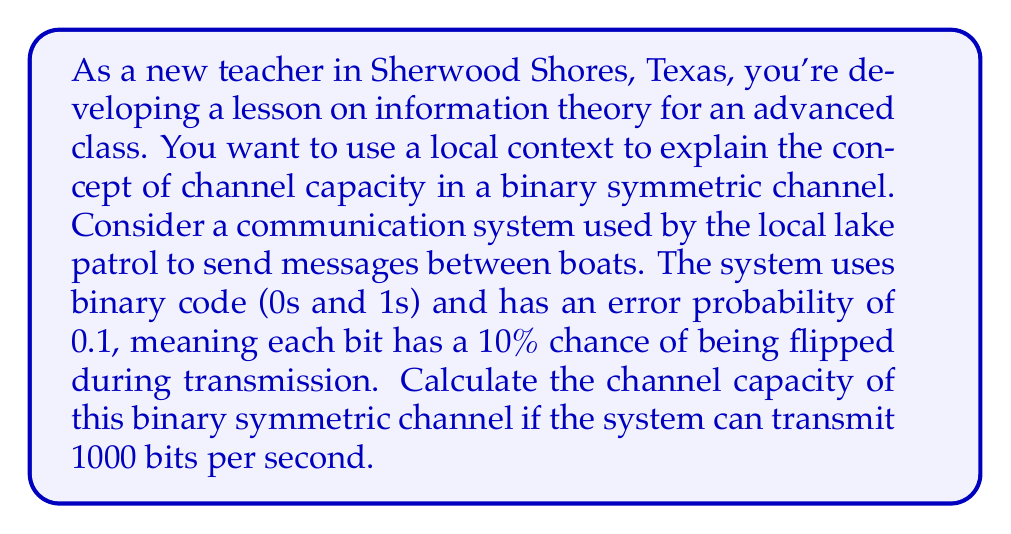Show me your answer to this math problem. To solve this problem, we'll use the formula for the channel capacity of a binary symmetric channel (BSC) and apply it to the given scenario. Let's break it down step-by-step:

1. The formula for the channel capacity (C) of a BSC is:

   $$C = 1 - H(p)$$

   where $H(p)$ is the binary entropy function and $p$ is the error probability.

2. The binary entropy function is defined as:

   $$H(p) = -p \log_2(p) - (1-p) \log_2(1-p)$$

3. We're given that the error probability $p = 0.1$. Let's calculate $H(0.1)$:

   $$\begin{align*}
   H(0.1) &= -0.1 \log_2(0.1) - 0.9 \log_2(0.9) \\
   &\approx 0.1 \cdot 3.32 + 0.9 \cdot 0.15 \\
   &\approx 0.332 + 0.135 \\
   &\approx 0.467
   \end{align*}$$

4. Now we can calculate the channel capacity:

   $$\begin{align*}
   C &= 1 - H(0.1) \\
   &= 1 - 0.467 \\
   &\approx 0.533
   \end{align*}$$

5. This means that for each use of the channel, we can transmit about 0.533 bits of information reliably.

6. Since the system can transmit 1000 bits per second, we multiply the capacity by 1000 to get the channel capacity in bits per second:

   $$\text{Channel Capacity} = 0.533 \cdot 1000 \approx 533 \text{ bits/second}$$

Therefore, the channel capacity of the lake patrol's communication system is approximately 533 bits per second.
Answer: The channel capacity is approximately 533 bits per second. 